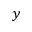Convert formula to latex. <formula><loc_0><loc_0><loc_500><loc_500>y</formula> 